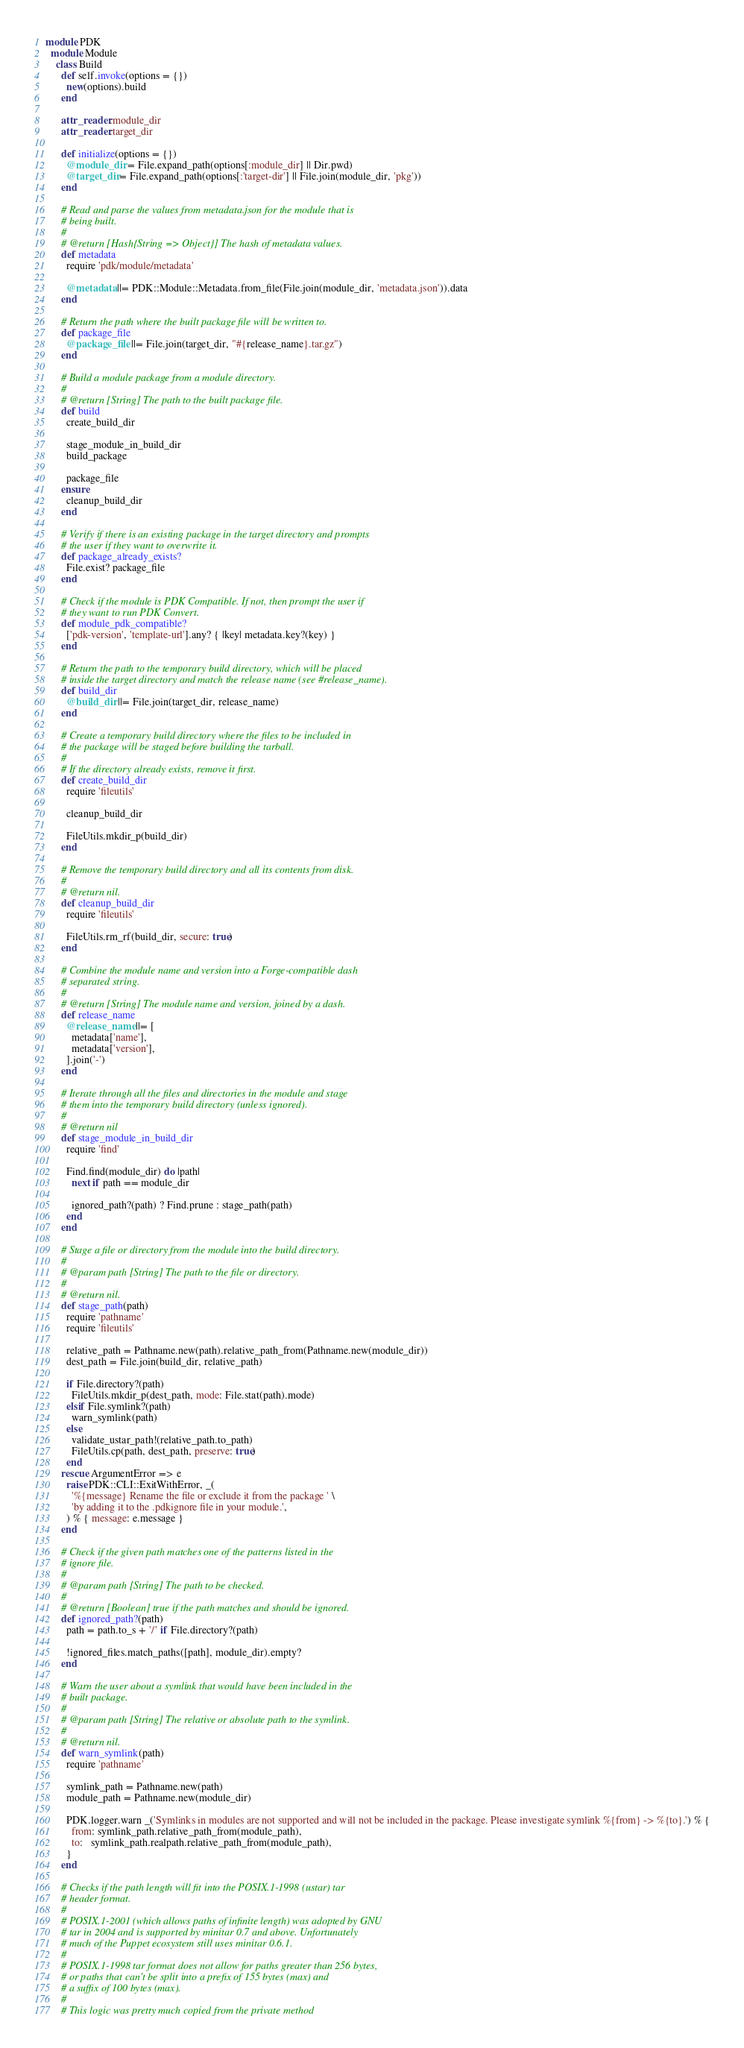<code> <loc_0><loc_0><loc_500><loc_500><_Ruby_>module PDK
  module Module
    class Build
      def self.invoke(options = {})
        new(options).build
      end

      attr_reader :module_dir
      attr_reader :target_dir

      def initialize(options = {})
        @module_dir = File.expand_path(options[:module_dir] || Dir.pwd)
        @target_dir = File.expand_path(options[:'target-dir'] || File.join(module_dir, 'pkg'))
      end

      # Read and parse the values from metadata.json for the module that is
      # being built.
      #
      # @return [Hash{String => Object}] The hash of metadata values.
      def metadata
        require 'pdk/module/metadata'

        @metadata ||= PDK::Module::Metadata.from_file(File.join(module_dir, 'metadata.json')).data
      end

      # Return the path where the built package file will be written to.
      def package_file
        @package_file ||= File.join(target_dir, "#{release_name}.tar.gz")
      end

      # Build a module package from a module directory.
      #
      # @return [String] The path to the built package file.
      def build
        create_build_dir

        stage_module_in_build_dir
        build_package

        package_file
      ensure
        cleanup_build_dir
      end

      # Verify if there is an existing package in the target directory and prompts
      # the user if they want to overwrite it.
      def package_already_exists?
        File.exist? package_file
      end

      # Check if the module is PDK Compatible. If not, then prompt the user if
      # they want to run PDK Convert.
      def module_pdk_compatible?
        ['pdk-version', 'template-url'].any? { |key| metadata.key?(key) }
      end

      # Return the path to the temporary build directory, which will be placed
      # inside the target directory and match the release name (see #release_name).
      def build_dir
        @build_dir ||= File.join(target_dir, release_name)
      end

      # Create a temporary build directory where the files to be included in
      # the package will be staged before building the tarball.
      #
      # If the directory already exists, remove it first.
      def create_build_dir
        require 'fileutils'

        cleanup_build_dir

        FileUtils.mkdir_p(build_dir)
      end

      # Remove the temporary build directory and all its contents from disk.
      #
      # @return nil.
      def cleanup_build_dir
        require 'fileutils'

        FileUtils.rm_rf(build_dir, secure: true)
      end

      # Combine the module name and version into a Forge-compatible dash
      # separated string.
      #
      # @return [String] The module name and version, joined by a dash.
      def release_name
        @release_name ||= [
          metadata['name'],
          metadata['version'],
        ].join('-')
      end

      # Iterate through all the files and directories in the module and stage
      # them into the temporary build directory (unless ignored).
      #
      # @return nil
      def stage_module_in_build_dir
        require 'find'

        Find.find(module_dir) do |path|
          next if path == module_dir

          ignored_path?(path) ? Find.prune : stage_path(path)
        end
      end

      # Stage a file or directory from the module into the build directory.
      #
      # @param path [String] The path to the file or directory.
      #
      # @return nil.
      def stage_path(path)
        require 'pathname'
        require 'fileutils'

        relative_path = Pathname.new(path).relative_path_from(Pathname.new(module_dir))
        dest_path = File.join(build_dir, relative_path)

        if File.directory?(path)
          FileUtils.mkdir_p(dest_path, mode: File.stat(path).mode)
        elsif File.symlink?(path)
          warn_symlink(path)
        else
          validate_ustar_path!(relative_path.to_path)
          FileUtils.cp(path, dest_path, preserve: true)
        end
      rescue ArgumentError => e
        raise PDK::CLI::ExitWithError, _(
          '%{message} Rename the file or exclude it from the package ' \
          'by adding it to the .pdkignore file in your module.',
        ) % { message: e.message }
      end

      # Check if the given path matches one of the patterns listed in the
      # ignore file.
      #
      # @param path [String] The path to be checked.
      #
      # @return [Boolean] true if the path matches and should be ignored.
      def ignored_path?(path)
        path = path.to_s + '/' if File.directory?(path)

        !ignored_files.match_paths([path], module_dir).empty?
      end

      # Warn the user about a symlink that would have been included in the
      # built package.
      #
      # @param path [String] The relative or absolute path to the symlink.
      #
      # @return nil.
      def warn_symlink(path)
        require 'pathname'

        symlink_path = Pathname.new(path)
        module_path = Pathname.new(module_dir)

        PDK.logger.warn _('Symlinks in modules are not supported and will not be included in the package. Please investigate symlink %{from} -> %{to}.') % {
          from: symlink_path.relative_path_from(module_path),
          to:   symlink_path.realpath.relative_path_from(module_path),
        }
      end

      # Checks if the path length will fit into the POSIX.1-1998 (ustar) tar
      # header format.
      #
      # POSIX.1-2001 (which allows paths of infinite length) was adopted by GNU
      # tar in 2004 and is supported by minitar 0.7 and above. Unfortunately
      # much of the Puppet ecosystem still uses minitar 0.6.1.
      #
      # POSIX.1-1998 tar format does not allow for paths greater than 256 bytes,
      # or paths that can't be split into a prefix of 155 bytes (max) and
      # a suffix of 100 bytes (max).
      #
      # This logic was pretty much copied from the private method</code> 